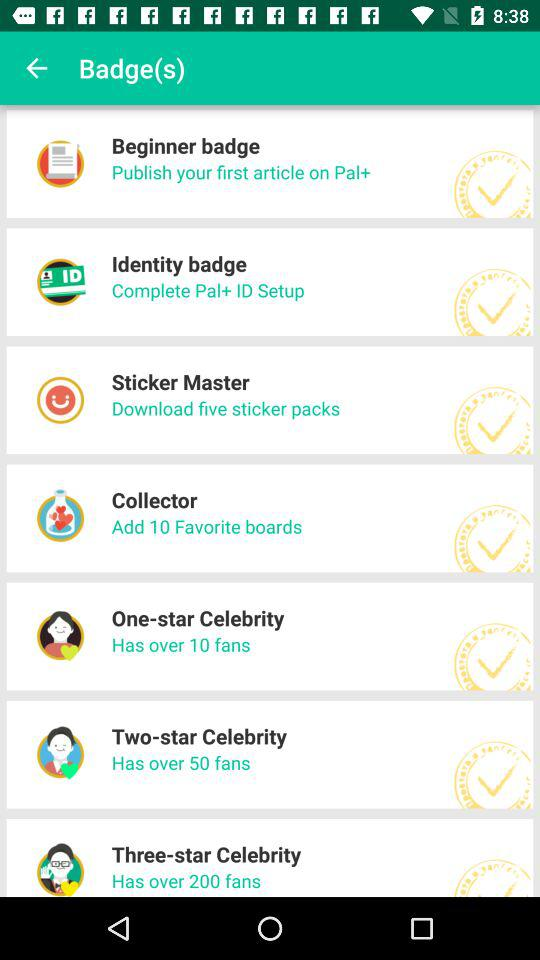How many fans does a one-star celebrity have? A one-star celebrity has over 10 fans. 